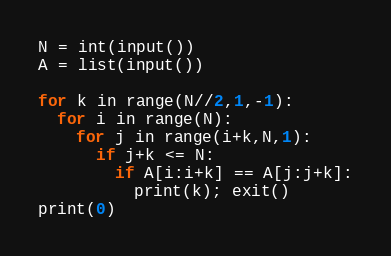<code> <loc_0><loc_0><loc_500><loc_500><_Python_>N = int(input())
A = list(input())

for k in range(N//2,1,-1):
  for i in range(N):
    for j in range(i+k,N,1):  
      if j+k <= N:
        if A[i:i+k] == A[j:j+k]:
          print(k); exit()
print(0)
</code> 